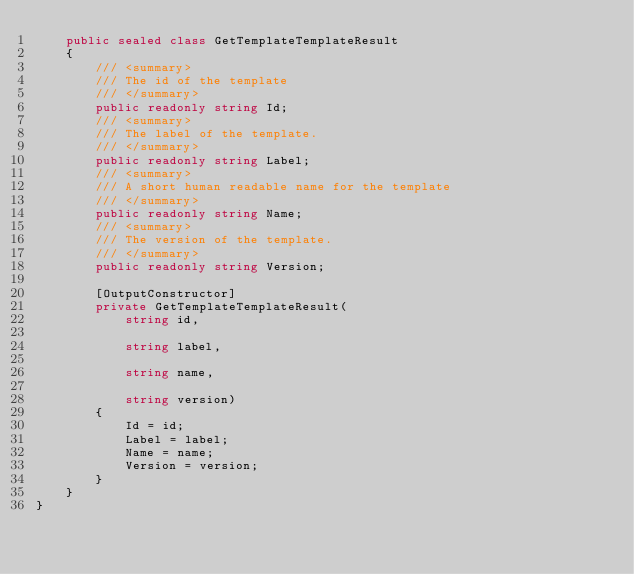Convert code to text. <code><loc_0><loc_0><loc_500><loc_500><_C#_>    public sealed class GetTemplateTemplateResult
    {
        /// <summary>
        /// The id of the template
        /// </summary>
        public readonly string Id;
        /// <summary>
        /// The label of the template.
        /// </summary>
        public readonly string Label;
        /// <summary>
        /// A short human readable name for the template
        /// </summary>
        public readonly string Name;
        /// <summary>
        /// The version of the template.
        /// </summary>
        public readonly string Version;

        [OutputConstructor]
        private GetTemplateTemplateResult(
            string id,

            string label,

            string name,

            string version)
        {
            Id = id;
            Label = label;
            Name = name;
            Version = version;
        }
    }
}
</code> 